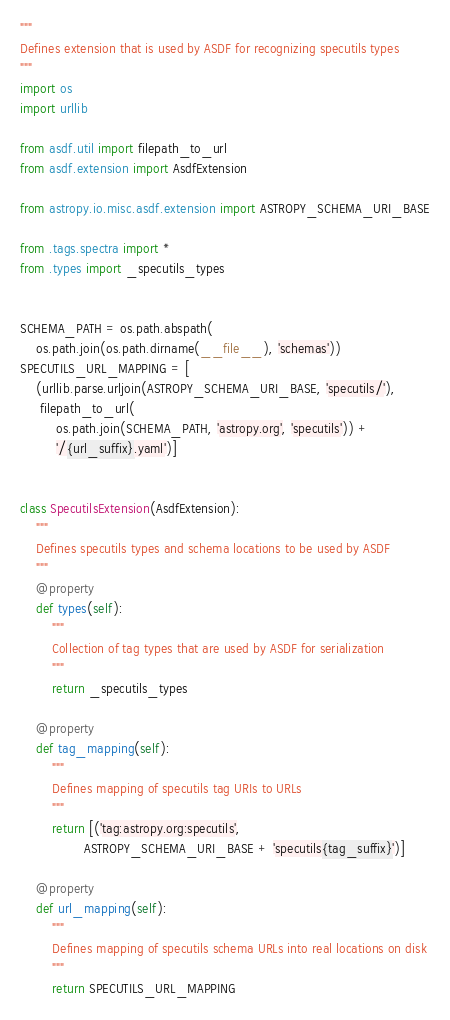Convert code to text. <code><loc_0><loc_0><loc_500><loc_500><_Python_>"""
Defines extension that is used by ASDF for recognizing specutils types
"""
import os
import urllib

from asdf.util import filepath_to_url
from asdf.extension import AsdfExtension

from astropy.io.misc.asdf.extension import ASTROPY_SCHEMA_URI_BASE

from .tags.spectra import *
from .types import _specutils_types


SCHEMA_PATH = os.path.abspath(
    os.path.join(os.path.dirname(__file__), 'schemas'))
SPECUTILS_URL_MAPPING = [
    (urllib.parse.urljoin(ASTROPY_SCHEMA_URI_BASE, 'specutils/'),
     filepath_to_url(
         os.path.join(SCHEMA_PATH, 'astropy.org', 'specutils')) +
         '/{url_suffix}.yaml')]


class SpecutilsExtension(AsdfExtension):
    """
    Defines specutils types and schema locations to be used by ASDF
    """
    @property
    def types(self):
        """
        Collection of tag types that are used by ASDF for serialization
        """
        return _specutils_types

    @property
    def tag_mapping(self):
        """
        Defines mapping of specutils tag URIs to URLs
        """
        return [('tag:astropy.org:specutils',
                ASTROPY_SCHEMA_URI_BASE + 'specutils{tag_suffix}')]

    @property
    def url_mapping(self):
        """
        Defines mapping of specutils schema URLs into real locations on disk
        """
        return SPECUTILS_URL_MAPPING
</code> 